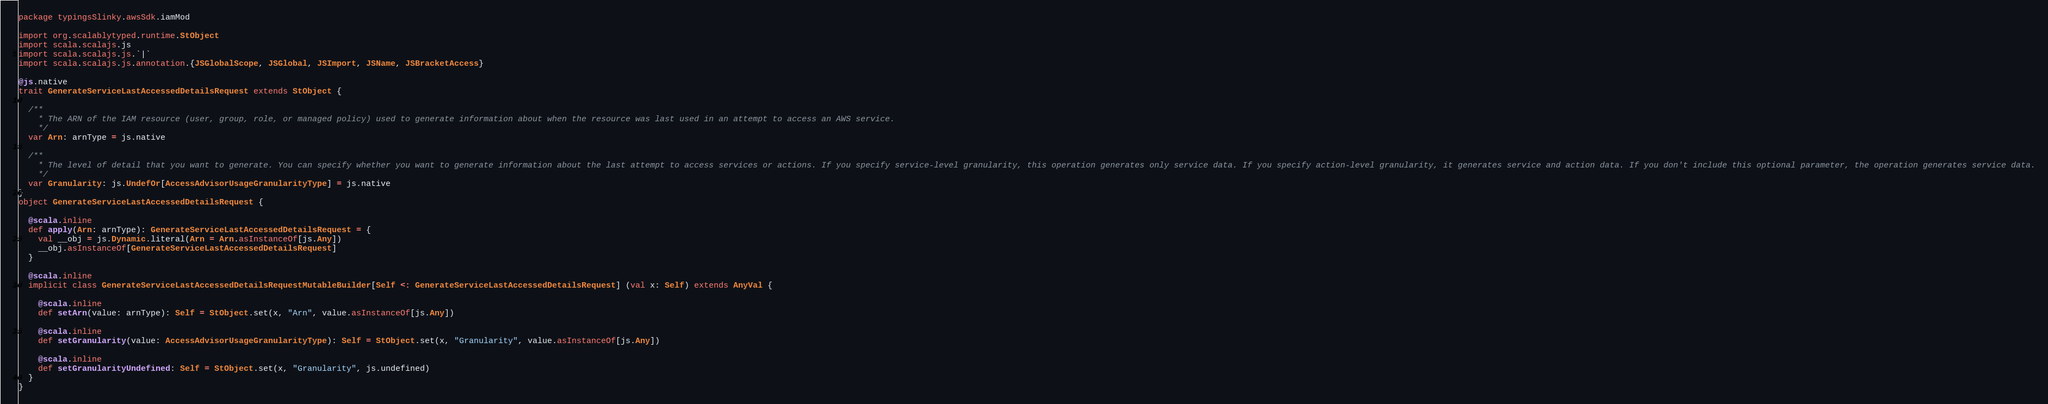Convert code to text. <code><loc_0><loc_0><loc_500><loc_500><_Scala_>package typingsSlinky.awsSdk.iamMod

import org.scalablytyped.runtime.StObject
import scala.scalajs.js
import scala.scalajs.js.`|`
import scala.scalajs.js.annotation.{JSGlobalScope, JSGlobal, JSImport, JSName, JSBracketAccess}

@js.native
trait GenerateServiceLastAccessedDetailsRequest extends StObject {
  
  /**
    * The ARN of the IAM resource (user, group, role, or managed policy) used to generate information about when the resource was last used in an attempt to access an AWS service.
    */
  var Arn: arnType = js.native
  
  /**
    * The level of detail that you want to generate. You can specify whether you want to generate information about the last attempt to access services or actions. If you specify service-level granularity, this operation generates only service data. If you specify action-level granularity, it generates service and action data. If you don't include this optional parameter, the operation generates service data.
    */
  var Granularity: js.UndefOr[AccessAdvisorUsageGranularityType] = js.native
}
object GenerateServiceLastAccessedDetailsRequest {
  
  @scala.inline
  def apply(Arn: arnType): GenerateServiceLastAccessedDetailsRequest = {
    val __obj = js.Dynamic.literal(Arn = Arn.asInstanceOf[js.Any])
    __obj.asInstanceOf[GenerateServiceLastAccessedDetailsRequest]
  }
  
  @scala.inline
  implicit class GenerateServiceLastAccessedDetailsRequestMutableBuilder[Self <: GenerateServiceLastAccessedDetailsRequest] (val x: Self) extends AnyVal {
    
    @scala.inline
    def setArn(value: arnType): Self = StObject.set(x, "Arn", value.asInstanceOf[js.Any])
    
    @scala.inline
    def setGranularity(value: AccessAdvisorUsageGranularityType): Self = StObject.set(x, "Granularity", value.asInstanceOf[js.Any])
    
    @scala.inline
    def setGranularityUndefined: Self = StObject.set(x, "Granularity", js.undefined)
  }
}
</code> 